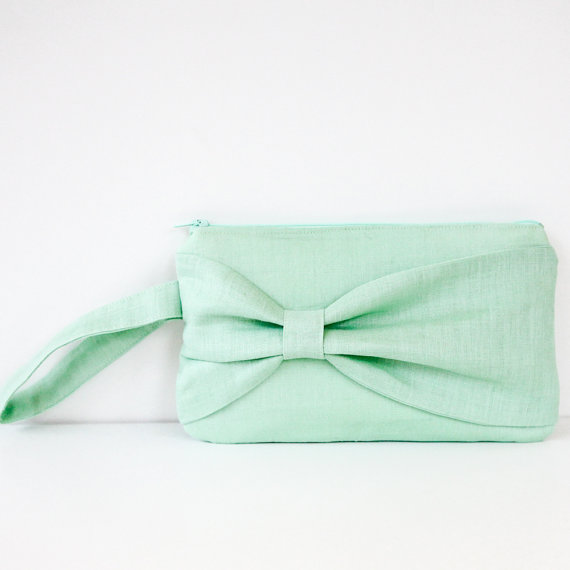How could this clutch purse influence the fashion trends of the upcoming season? This mint green clutch purse, with its soft color and elegant bow, could set a trend for minimalist yet charming accessories in the upcoming spring and summer seasons. Its design emphasizes simplicity combined with a touch of whimsy, inspiring designers to create pieces that are both understated and eye-catching. The pastel color palette might surge in popularity, leading to a wave of apparel and accessories in similarly soothing hues. Additionally, the bow detail could become a favored accent, appearing on belts, shoes, and other fashion items, symbolizing a return to graceful, vintage-inspired styles. Brands might also adopt more eco-friendly materials in their designs, reflecting a growing trend towards sustainability in fashion. 